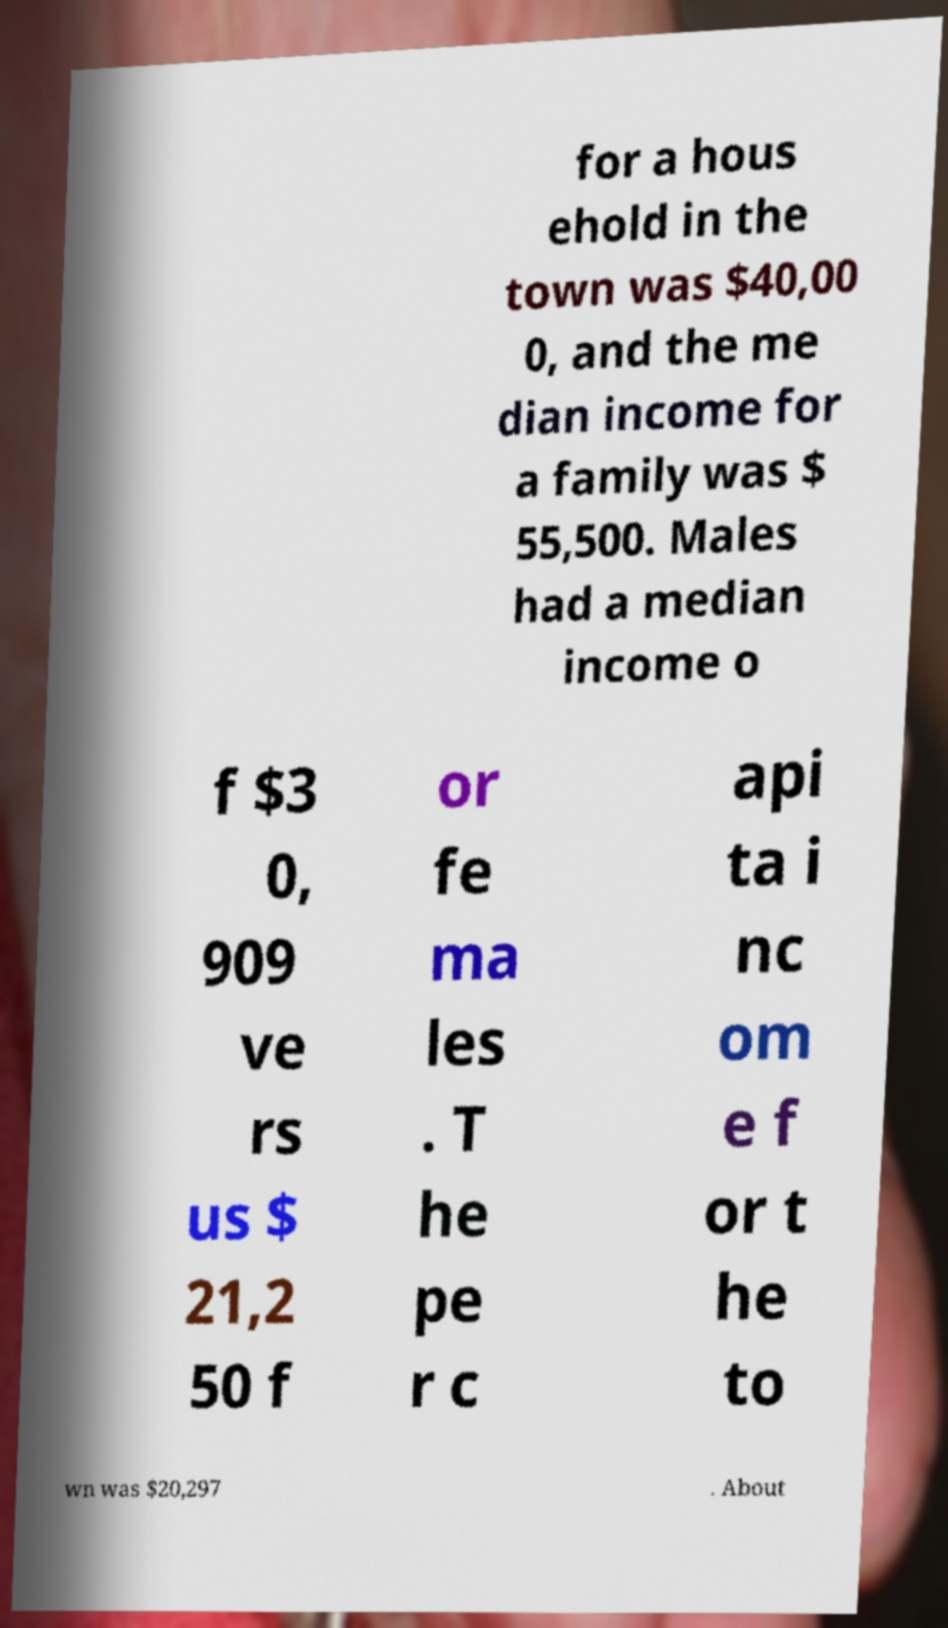Please read and relay the text visible in this image. What does it say? for a hous ehold in the town was $40,00 0, and the me dian income for a family was $ 55,500. Males had a median income o f $3 0, 909 ve rs us $ 21,2 50 f or fe ma les . T he pe r c api ta i nc om e f or t he to wn was $20,297 . About 